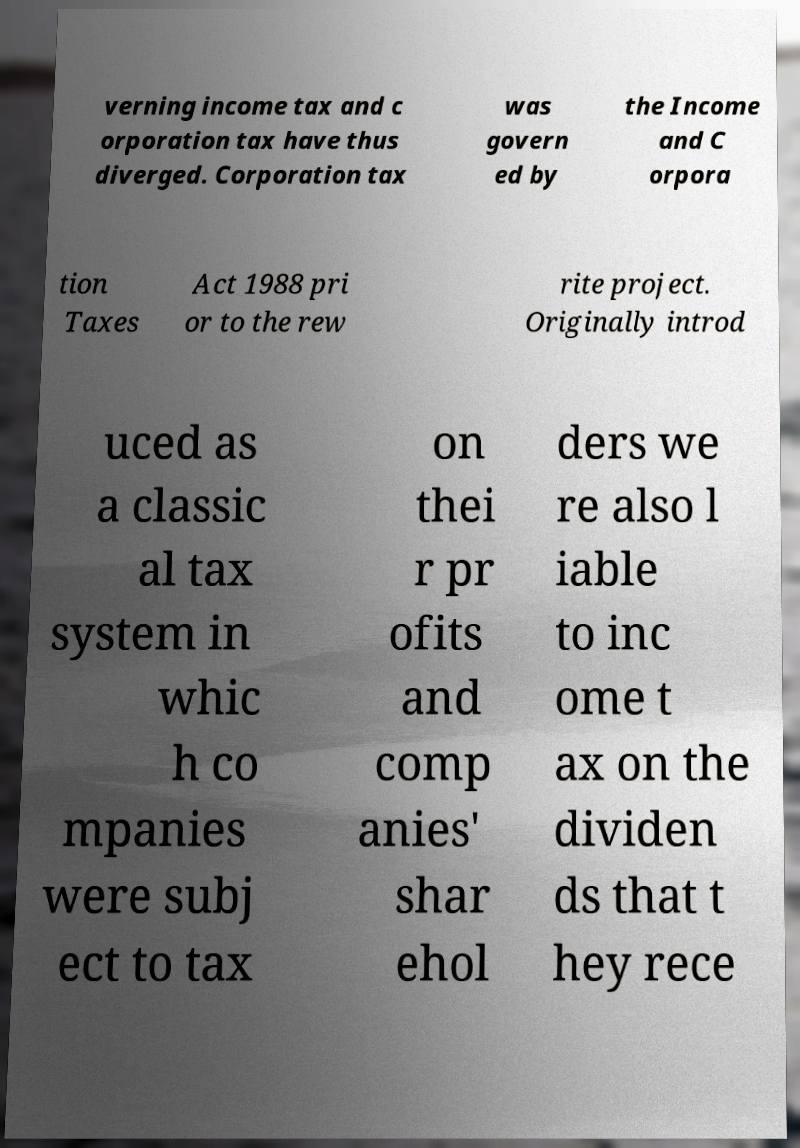Can you accurately transcribe the text from the provided image for me? verning income tax and c orporation tax have thus diverged. Corporation tax was govern ed by the Income and C orpora tion Taxes Act 1988 pri or to the rew rite project. Originally introd uced as a classic al tax system in whic h co mpanies were subj ect to tax on thei r pr ofits and comp anies' shar ehol ders we re also l iable to inc ome t ax on the dividen ds that t hey rece 